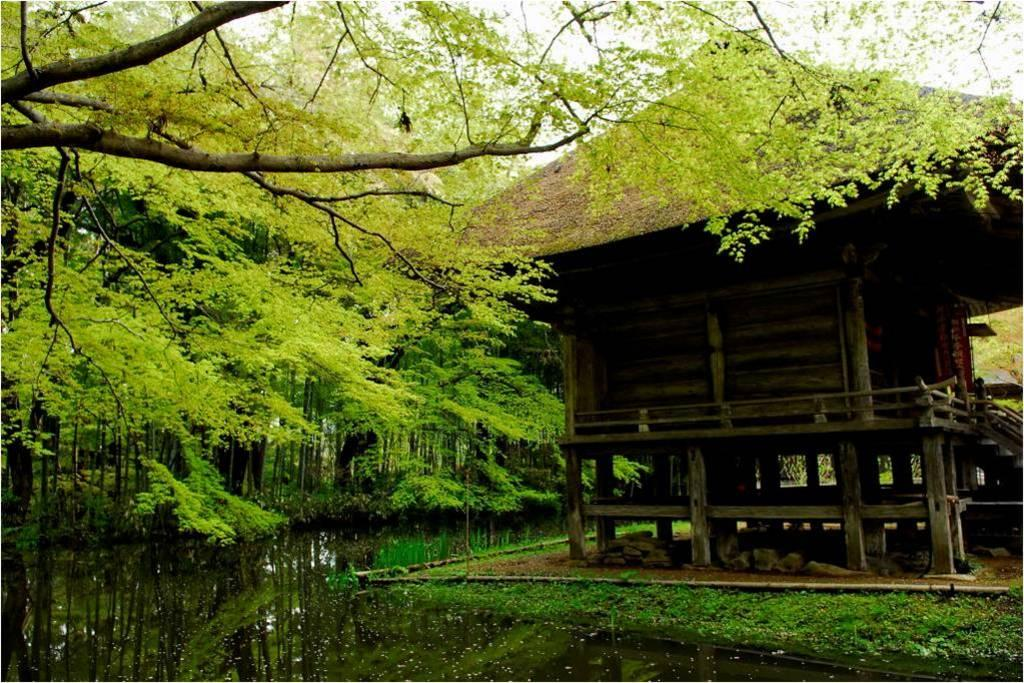What is the primary element visible in the image? There is water in the image. What type of vegetation can be seen in the image? There are trees in the image. What type of structure is present in the image? There is a hut in the image. What type of yoke is being used to control the water in the image? There is no yoke present in the image, and the water is not being controlled by any such device. How many feet are visible in the image? There is no reference to feet or any body parts in the image, so it is not possible to determine how many feet are visible. 